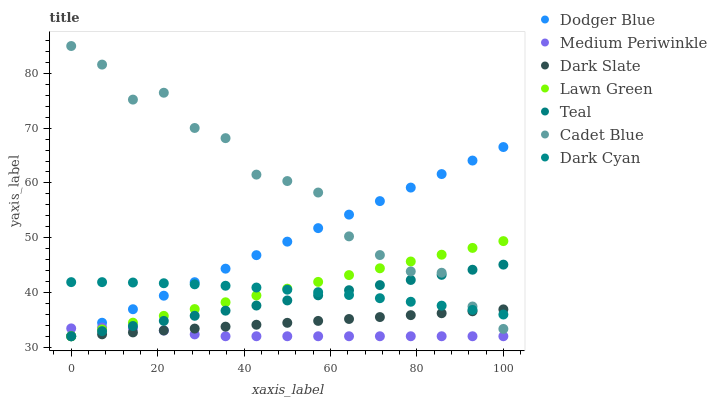Does Medium Periwinkle have the minimum area under the curve?
Answer yes or no. Yes. Does Cadet Blue have the maximum area under the curve?
Answer yes or no. Yes. Does Cadet Blue have the minimum area under the curve?
Answer yes or no. No. Does Medium Periwinkle have the maximum area under the curve?
Answer yes or no. No. Is Teal the smoothest?
Answer yes or no. Yes. Is Cadet Blue the roughest?
Answer yes or no. Yes. Is Medium Periwinkle the smoothest?
Answer yes or no. No. Is Medium Periwinkle the roughest?
Answer yes or no. No. Does Lawn Green have the lowest value?
Answer yes or no. Yes. Does Cadet Blue have the lowest value?
Answer yes or no. No. Does Cadet Blue have the highest value?
Answer yes or no. Yes. Does Medium Periwinkle have the highest value?
Answer yes or no. No. Is Medium Periwinkle less than Dark Cyan?
Answer yes or no. Yes. Is Dark Cyan greater than Medium Periwinkle?
Answer yes or no. Yes. Does Dodger Blue intersect Cadet Blue?
Answer yes or no. Yes. Is Dodger Blue less than Cadet Blue?
Answer yes or no. No. Is Dodger Blue greater than Cadet Blue?
Answer yes or no. No. Does Medium Periwinkle intersect Dark Cyan?
Answer yes or no. No. 